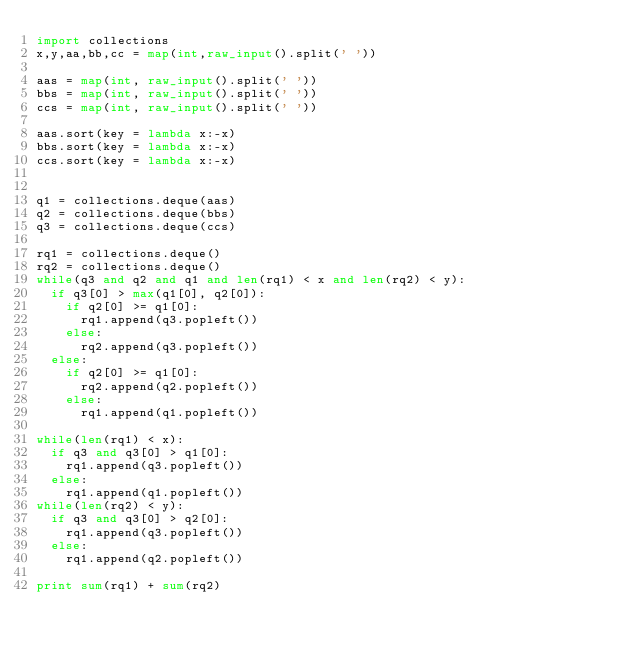Convert code to text. <code><loc_0><loc_0><loc_500><loc_500><_Python_>import collections
x,y,aa,bb,cc = map(int,raw_input().split(' '))

aas = map(int, raw_input().split(' '))
bbs = map(int, raw_input().split(' '))
ccs = map(int, raw_input().split(' '))

aas.sort(key = lambda x:-x)
bbs.sort(key = lambda x:-x)
ccs.sort(key = lambda x:-x)


q1 = collections.deque(aas)
q2 = collections.deque(bbs)
q3 = collections.deque(ccs)

rq1 = collections.deque()
rq2 = collections.deque()
while(q3 and q2 and q1 and len(rq1) < x and len(rq2) < y):
	if q3[0] > max(q1[0], q2[0]):
		if q2[0] >= q1[0]:
			rq1.append(q3.popleft())
		else:
			rq2.append(q3.popleft())
	else:
		if q2[0] >= q1[0]:
			rq2.append(q2.popleft())
		else:
			rq1.append(q1.popleft())

while(len(rq1) < x):
	if q3 and q3[0] > q1[0]:
		rq1.append(q3.popleft())
	else:
		rq1.append(q1.popleft())
while(len(rq2) < y):
	if q3 and q3[0] > q2[0]:
		rq1.append(q3.popleft())
	else:
		rq1.append(q2.popleft())

print sum(rq1) + sum(rq2)
</code> 